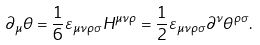Convert formula to latex. <formula><loc_0><loc_0><loc_500><loc_500>\partial _ { \mu } \theta = \frac { 1 } { 6 } \varepsilon _ { \mu \nu \rho \sigma } H ^ { \mu \nu \rho } = \frac { 1 } { 2 } \varepsilon _ { \mu \nu \rho \sigma } \partial ^ { \nu } \theta ^ { \rho \sigma } .</formula> 